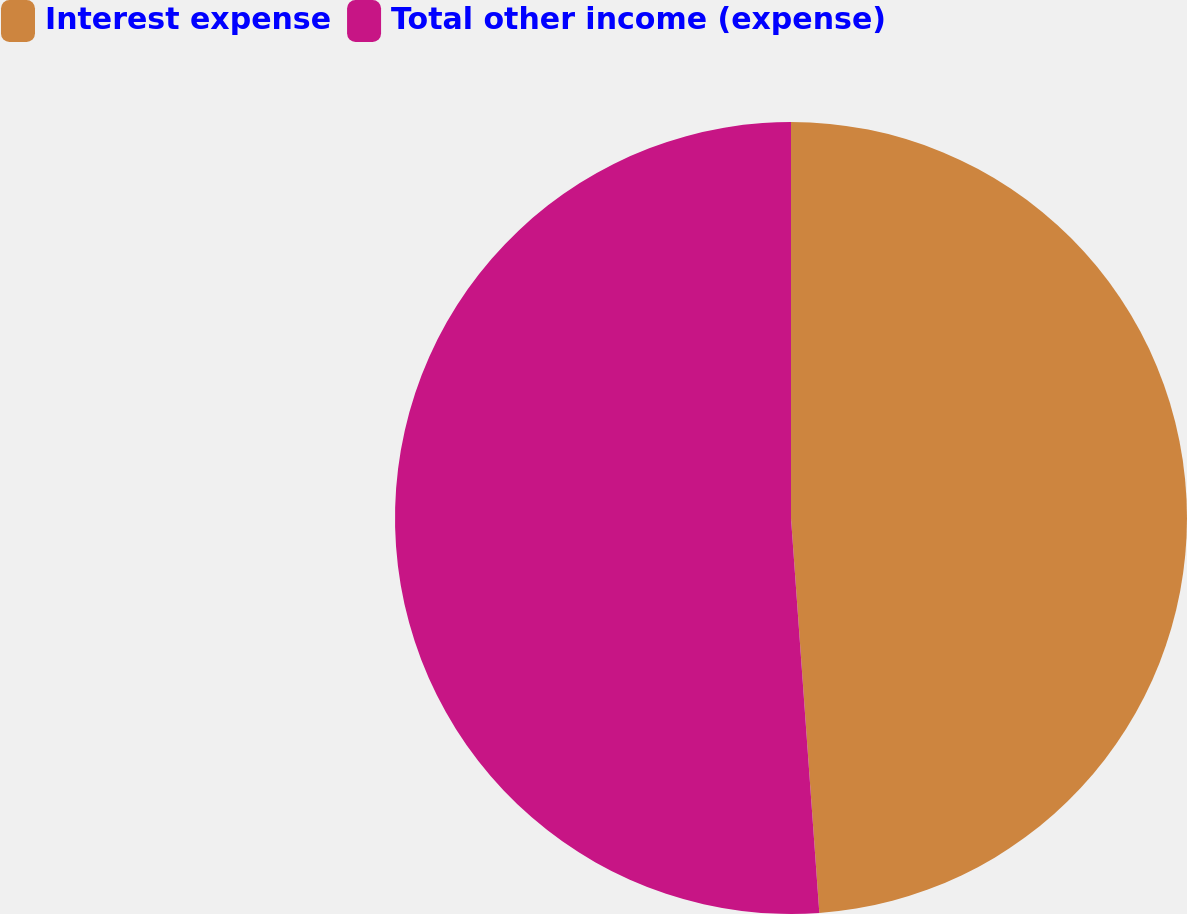Convert chart. <chart><loc_0><loc_0><loc_500><loc_500><pie_chart><fcel>Interest expense<fcel>Total other income (expense)<nl><fcel>48.86%<fcel>51.14%<nl></chart> 